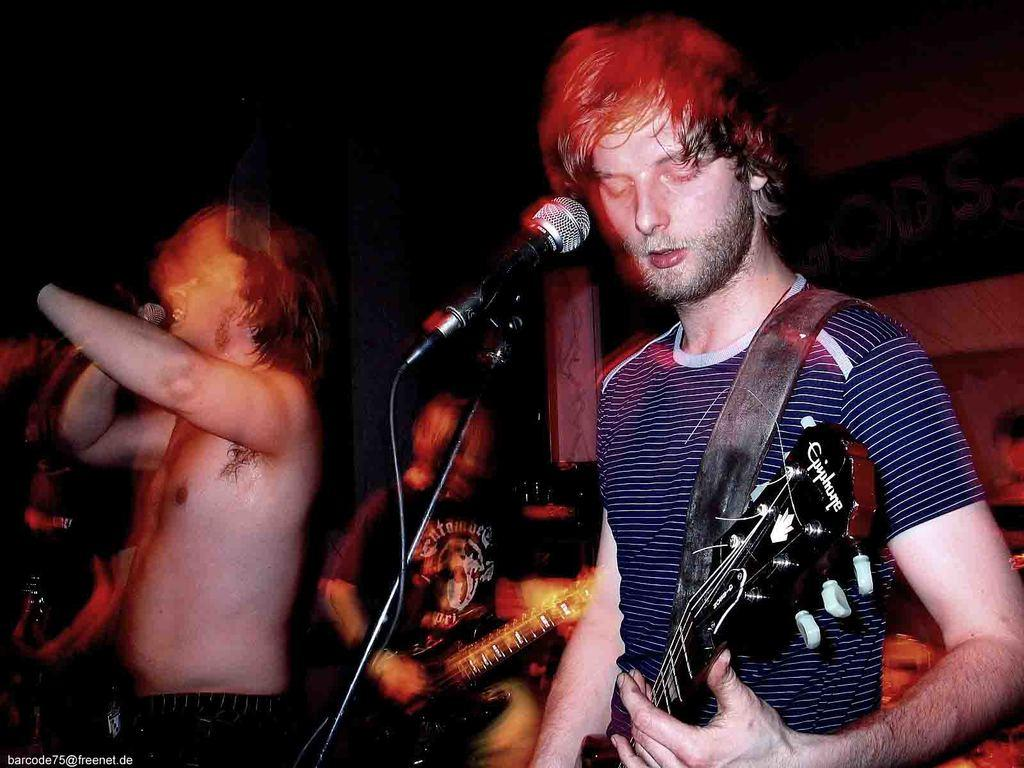What is the lighting condition in the image? The background of the image is dark. What are the two persons in the image doing? They are playing guitar. Can you describe the person holding the microphone? The person holding the microphone is singing. Is there any indication of the image quality? The image may be blurry. What type of sweater is the person wearing in the image? There is no mention of a sweater in the image, so it cannot be determined what type of sweater the person might be wearing. 